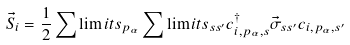<formula> <loc_0><loc_0><loc_500><loc_500>\vec { S } _ { i } = \frac { 1 } { 2 } \sum \lim i t s _ { p _ { \alpha } } \sum \lim i t s _ { s s ^ { \prime } } c ^ { \dag } _ { i , p _ { \alpha } , s } \vec { \sigma } _ { s s ^ { \prime } } c _ { i , p _ { \alpha } , s ^ { \prime } }</formula> 